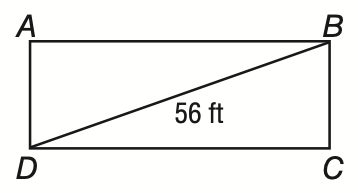Answer the mathemtical geometry problem and directly provide the correct option letter.
Question: The diagonals of rectangle A B C D the have a length of 56 feet. If m \angle B A C = 42, what is the length of A B to the nearest tenth of a foot?
Choices: A: 41.6 B: 50.4 C: 56.3 D: 75.4 A 